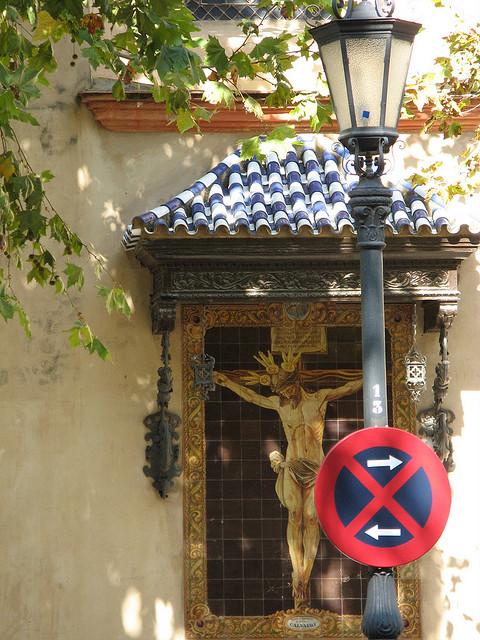Can you go both directions?
Write a very short answer. No. What is pictured behind the lamp post?
Short answer required. Jesus. Is the lamp on?
Answer briefly. No. 